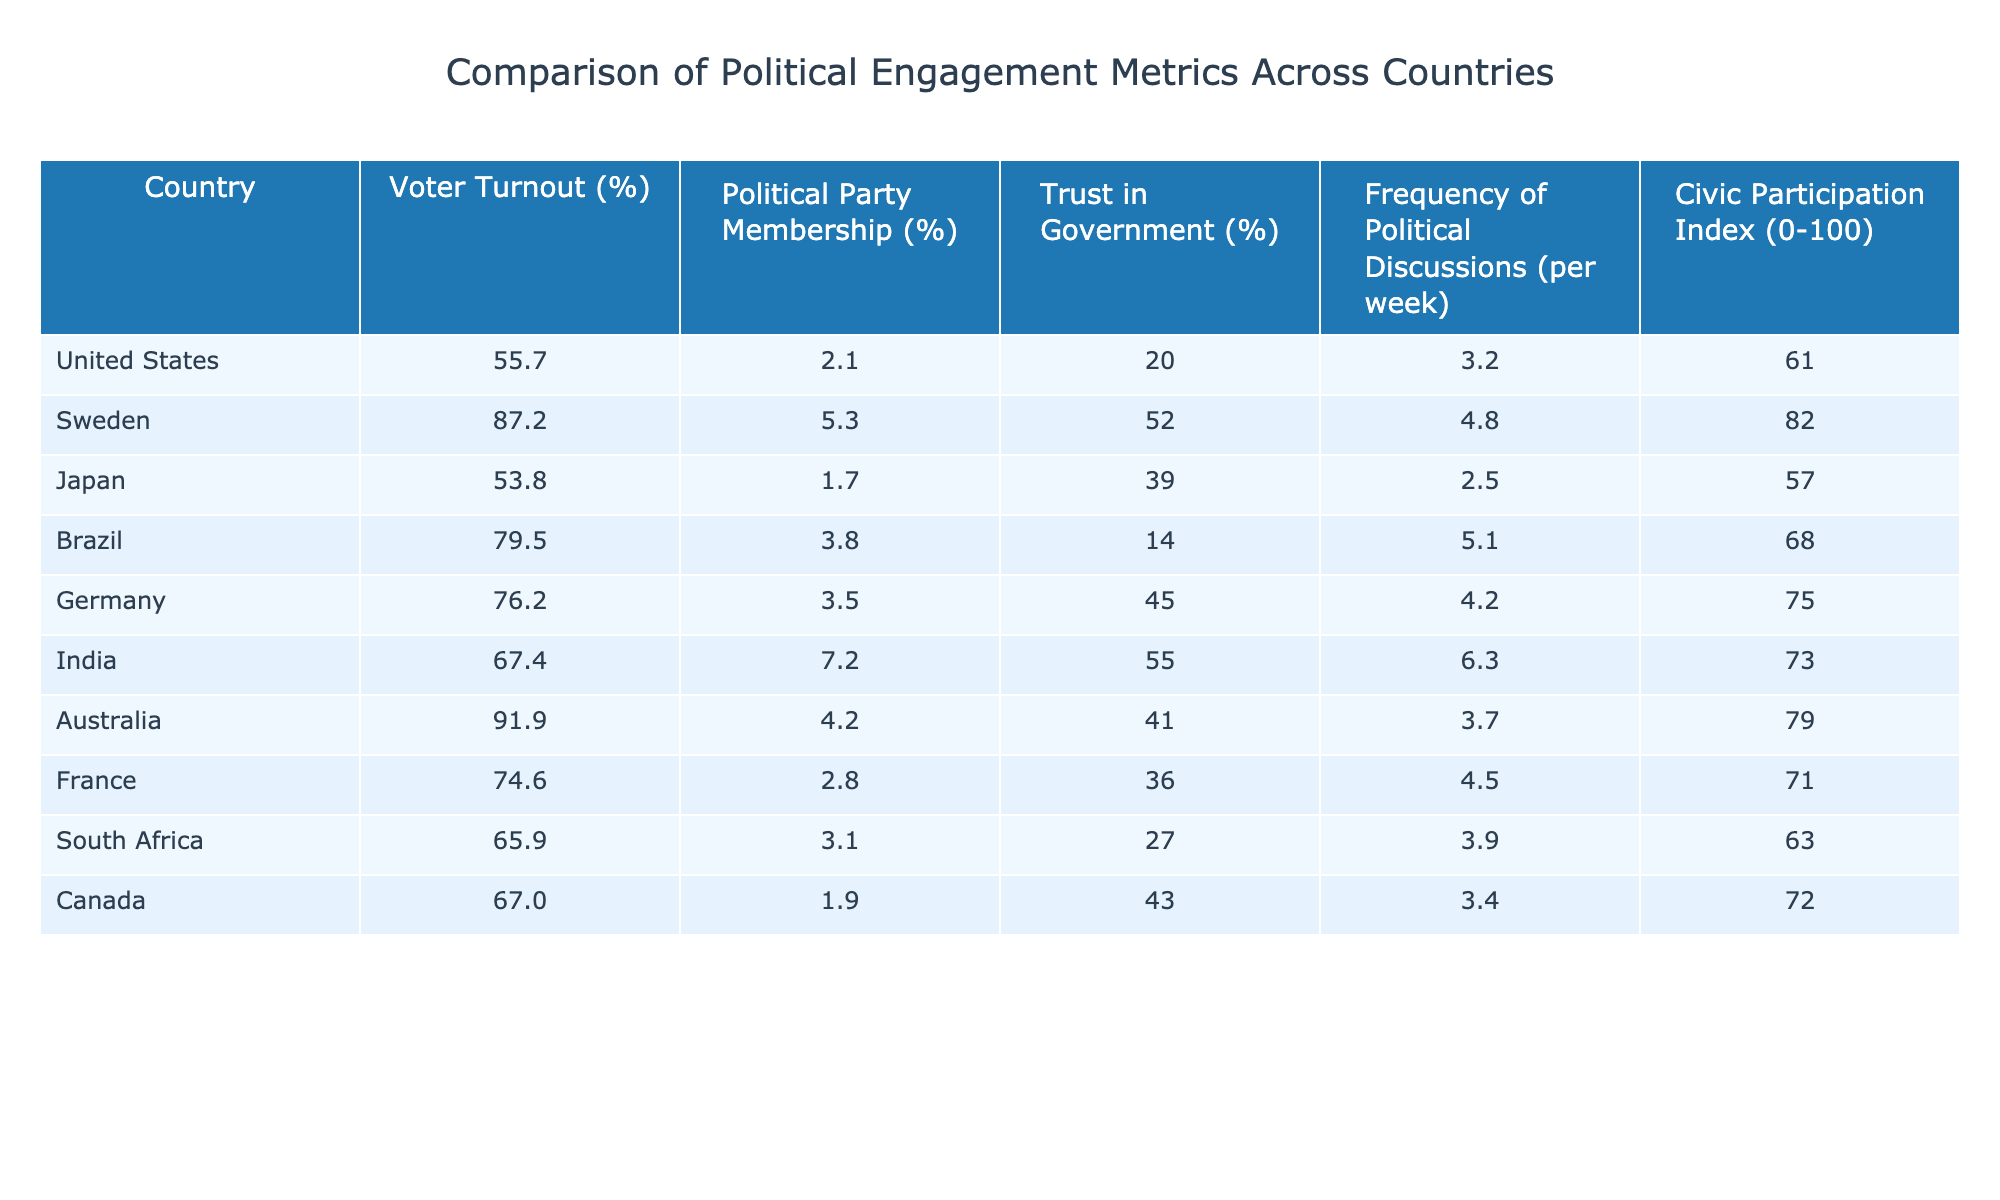What is the voter turnout in Sweden? The table indicates that the voter turnout percentage for Sweden is listed directly under the "Voter Turnout (%)" column. It shows a value of 87.2%.
Answer: 87.2% Which country has the highest trust in government? By inspecting the "Trust in Government (%)" column, Australia has a trust level of 41%, which is the highest percentage compared to other countries listed in the table.
Answer: Australia What is the difference in civic participation index between Germany and Brazil? The Civic Participation Index for Germany is 75 and for Brazil is 68. The difference is calculated as 75 - 68 = 7.
Answer: 7 What is the average voter turnout of the countries listed? To calculate the average voter turnout, sum all the voter turnouts: (55.7 + 87.2 + 53.8 + 79.5 + 76.2 + 67.4 + 91.9 + 74.6 + 65.9 + 67.0) and divide by the number of countries (10). The sum is 788.2, so the average is 788.2 / 10 = 78.82.
Answer: 78.8 Is voter turnout in South Africa greater than that of Canada? In the table, South Africa's voter turnout is 65.9% and Canada's is 67.0%. Comparing these values shows that 65.9% is not greater than 67.0%, so the statement is false.
Answer: No Which country exhibits the lowest frequency of political discussions per week? Looking at the "Frequency of Political Discussions (per week)" column, Japan has the lowest frequency at 2.5 discussions per week.
Answer: Japan How many countries have a political party membership percentage greater than 5? By reviewing the "Political Party Membership (%)" column, only India (7.2) and Sweden (5.3) meet this criterion, totaling 2 countries with a membership greater than 5%.
Answer: 2 What is the sum of voter turnout percentages for all the countries? Adding the voter turnouts yields: 55.7 + 87.2 + 53.8 + 79.5 + 76.2 + 67.4 + 91.9 + 74.6 + 65.9 + 67.0 which sums to 788.2%.
Answer: 788.2 Which two countries have the closest civic participation index? Inspecting the "Civic Participation Index", Canada has 72 and South Africa has 63. The difference is 9, making them the closest based on the indices provided.
Answer: Canada and South Africa Is trust in government in Brazil higher than in South Africa? The trust levels show Brazil at 14% and South Africa at 27%. Since 14% is lower than 27%, the statement is false.
Answer: No 